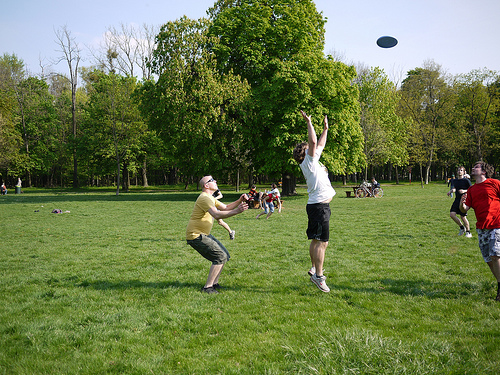Imagine if the frisbee could talk. What might it say about its frequent flyers? Oh, the adventures I have with my flyers! They toss me high into the air, sending me soaring towards the sky before I come sailing down. The excitement, the laughter, the way they leap and dive to catch me - it's exhilarating! Each game brings new stories, new faces, and endless fun. I get to witness their determination, joy, and camaraderie. It's a fantastic life for a frisbee! 